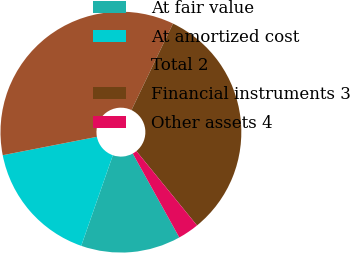<chart> <loc_0><loc_0><loc_500><loc_500><pie_chart><fcel>At fair value<fcel>At amortized cost<fcel>Total 2<fcel>Financial instruments 3<fcel>Other assets 4<nl><fcel>13.4%<fcel>16.59%<fcel>35.19%<fcel>31.99%<fcel>2.83%<nl></chart> 